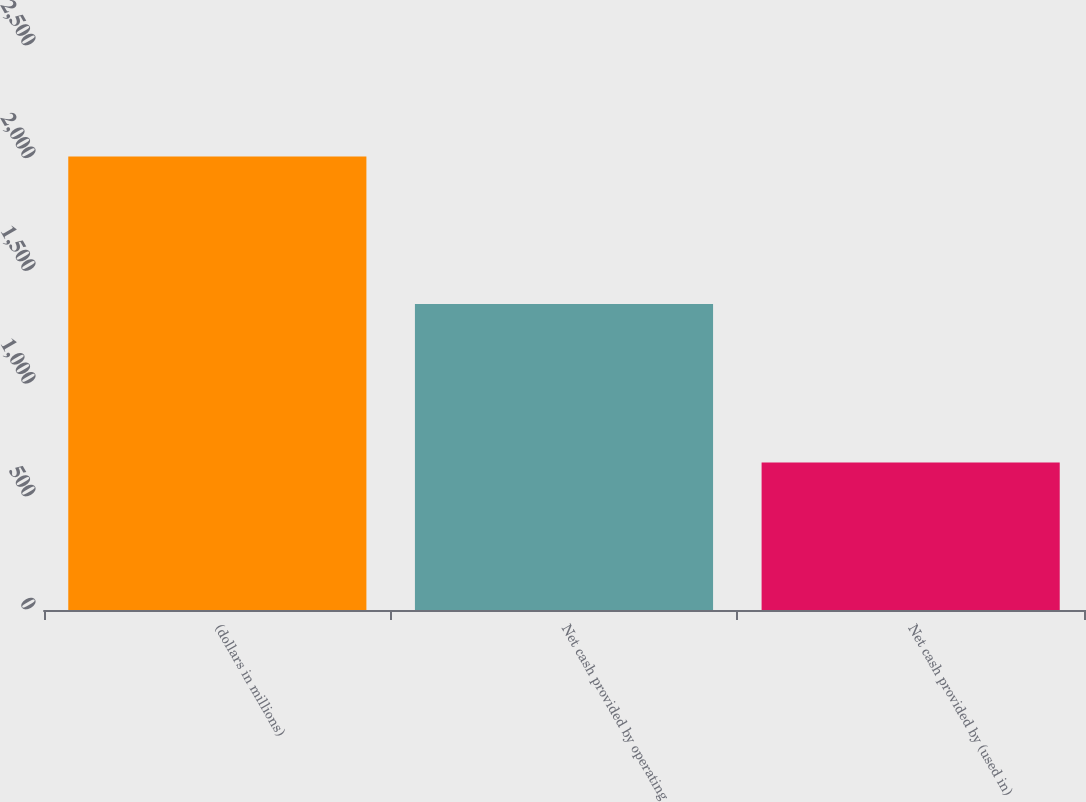Convert chart. <chart><loc_0><loc_0><loc_500><loc_500><bar_chart><fcel>(dollars in millions)<fcel>Net cash provided by operating<fcel>Net cash provided by (used in)<nl><fcel>2010<fcel>1356.4<fcel>653.4<nl></chart> 